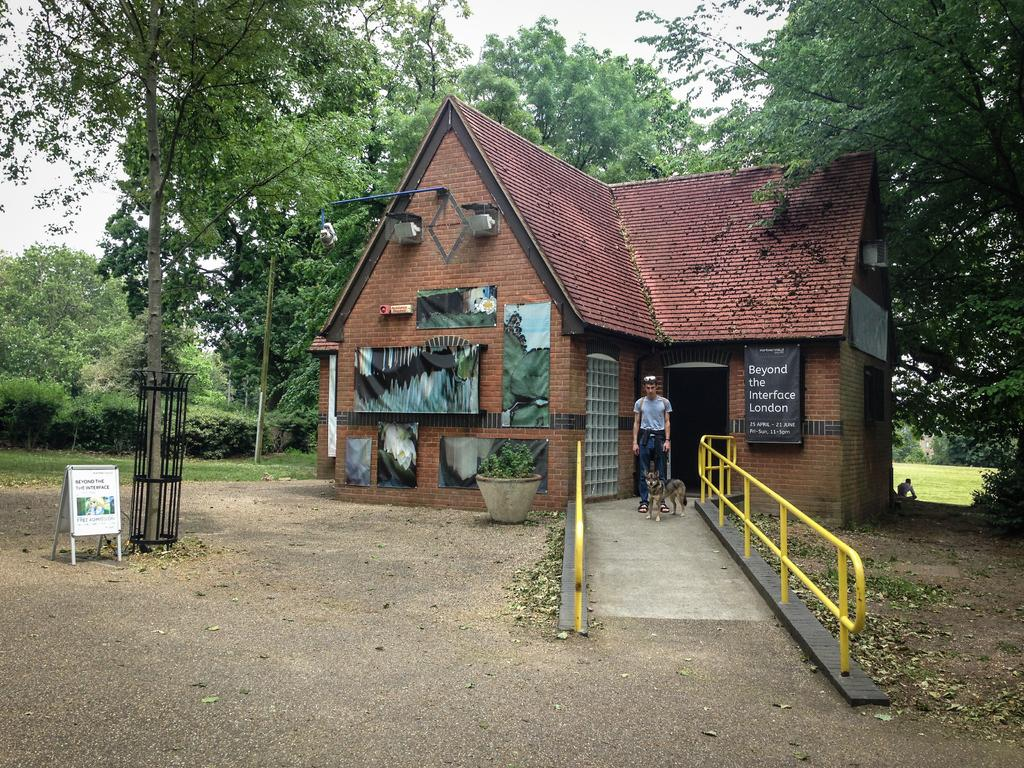<image>
Render a clear and concise summary of the photo. an outside exterior shot of a brick building with sign for Beyond the Interface London 